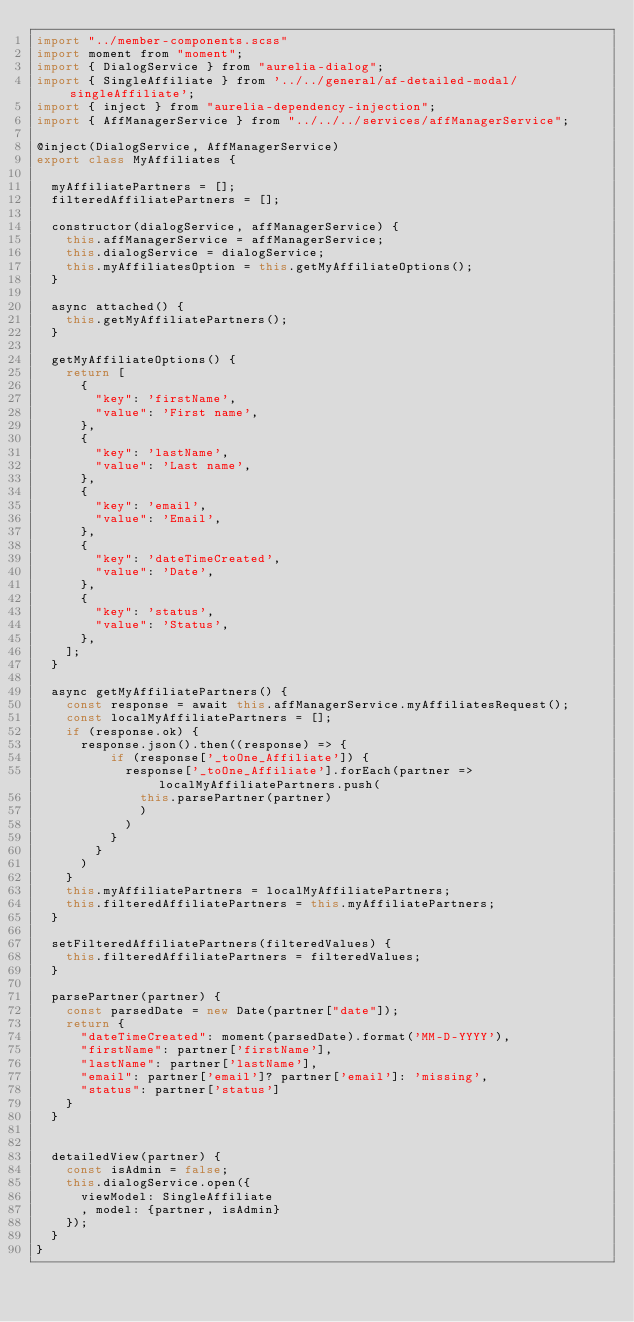Convert code to text. <code><loc_0><loc_0><loc_500><loc_500><_JavaScript_>import "../member-components.scss"
import moment from "moment";
import { DialogService } from "aurelia-dialog";
import { SingleAffiliate } from '../../general/af-detailed-modal/singleAffiliate';
import { inject } from "aurelia-dependency-injection";
import { AffManagerService } from "../../../services/affManagerService";

@inject(DialogService, AffManagerService)
export class MyAffiliates {

  myAffiliatePartners = [];
  filteredAffiliatePartners = [];

  constructor(dialogService, affManagerService) {
    this.affManagerService = affManagerService;
    this.dialogService = dialogService;
    this.myAffiliatesOption = this.getMyAffiliateOptions();
  }

  async attached() {
    this.getMyAffiliatePartners();
  }

  getMyAffiliateOptions() {
    return [
      {
        "key": 'firstName',
        "value": 'First name',
      },
      {
        "key": 'lastName',
        "value": 'Last name',
      },
      {
        "key": 'email',
        "value": 'Email',
      },
      {
        "key": 'dateTimeCreated',
        "value": 'Date',
      },
      {
        "key": 'status',
        "value": 'Status',
      },
    ];
  }

  async getMyAffiliatePartners() {
    const response = await this.affManagerService.myAffiliatesRequest();
    const localMyAffiliatePartners = [];
    if (response.ok) {
      response.json().then((response) => {
          if (response['_toOne_Affiliate']) {
            response['_toOne_Affiliate'].forEach(partner => localMyAffiliatePartners.push(
              this.parsePartner(partner)
              )
            )
          }
        }
      )
    }
    this.myAffiliatePartners = localMyAffiliatePartners;
    this.filteredAffiliatePartners = this.myAffiliatePartners;
  }

  setFilteredAffiliatePartners(filteredValues) {
    this.filteredAffiliatePartners = filteredValues;
  }

  parsePartner(partner) {
    const parsedDate = new Date(partner["date"]);
    return {
      "dateTimeCreated": moment(parsedDate).format('MM-D-YYYY'),
      "firstName": partner['firstName'],
      "lastName": partner['lastName'],
      "email": partner['email']? partner['email']: 'missing',
      "status": partner['status']
    }
  }


  detailedView(partner) {
    const isAdmin = false;
    this.dialogService.open({
      viewModel: SingleAffiliate
      , model: {partner, isAdmin}
    });
  }
}

</code> 